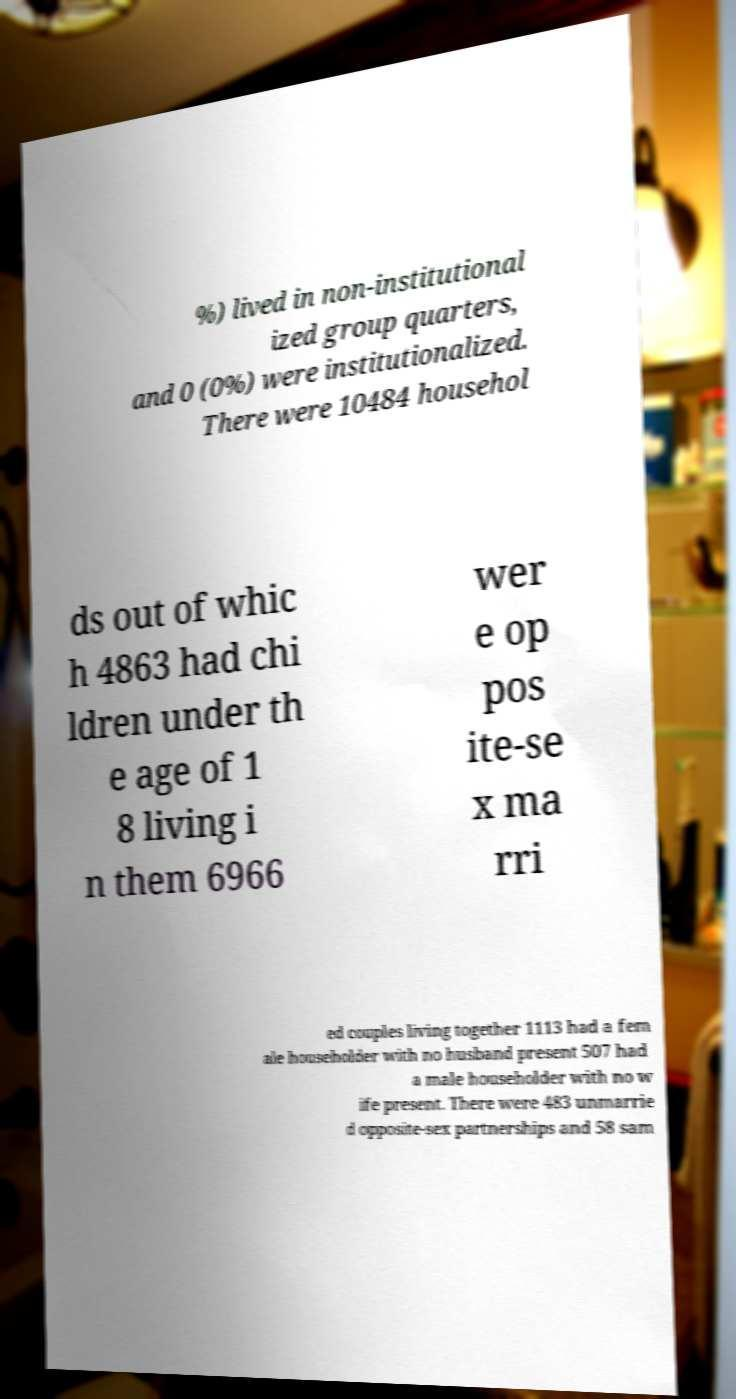Can you accurately transcribe the text from the provided image for me? %) lived in non-institutional ized group quarters, and 0 (0%) were institutionalized. There were 10484 househol ds out of whic h 4863 had chi ldren under th e age of 1 8 living i n them 6966 wer e op pos ite-se x ma rri ed couples living together 1113 had a fem ale householder with no husband present 507 had a male householder with no w ife present. There were 483 unmarrie d opposite-sex partnerships and 58 sam 